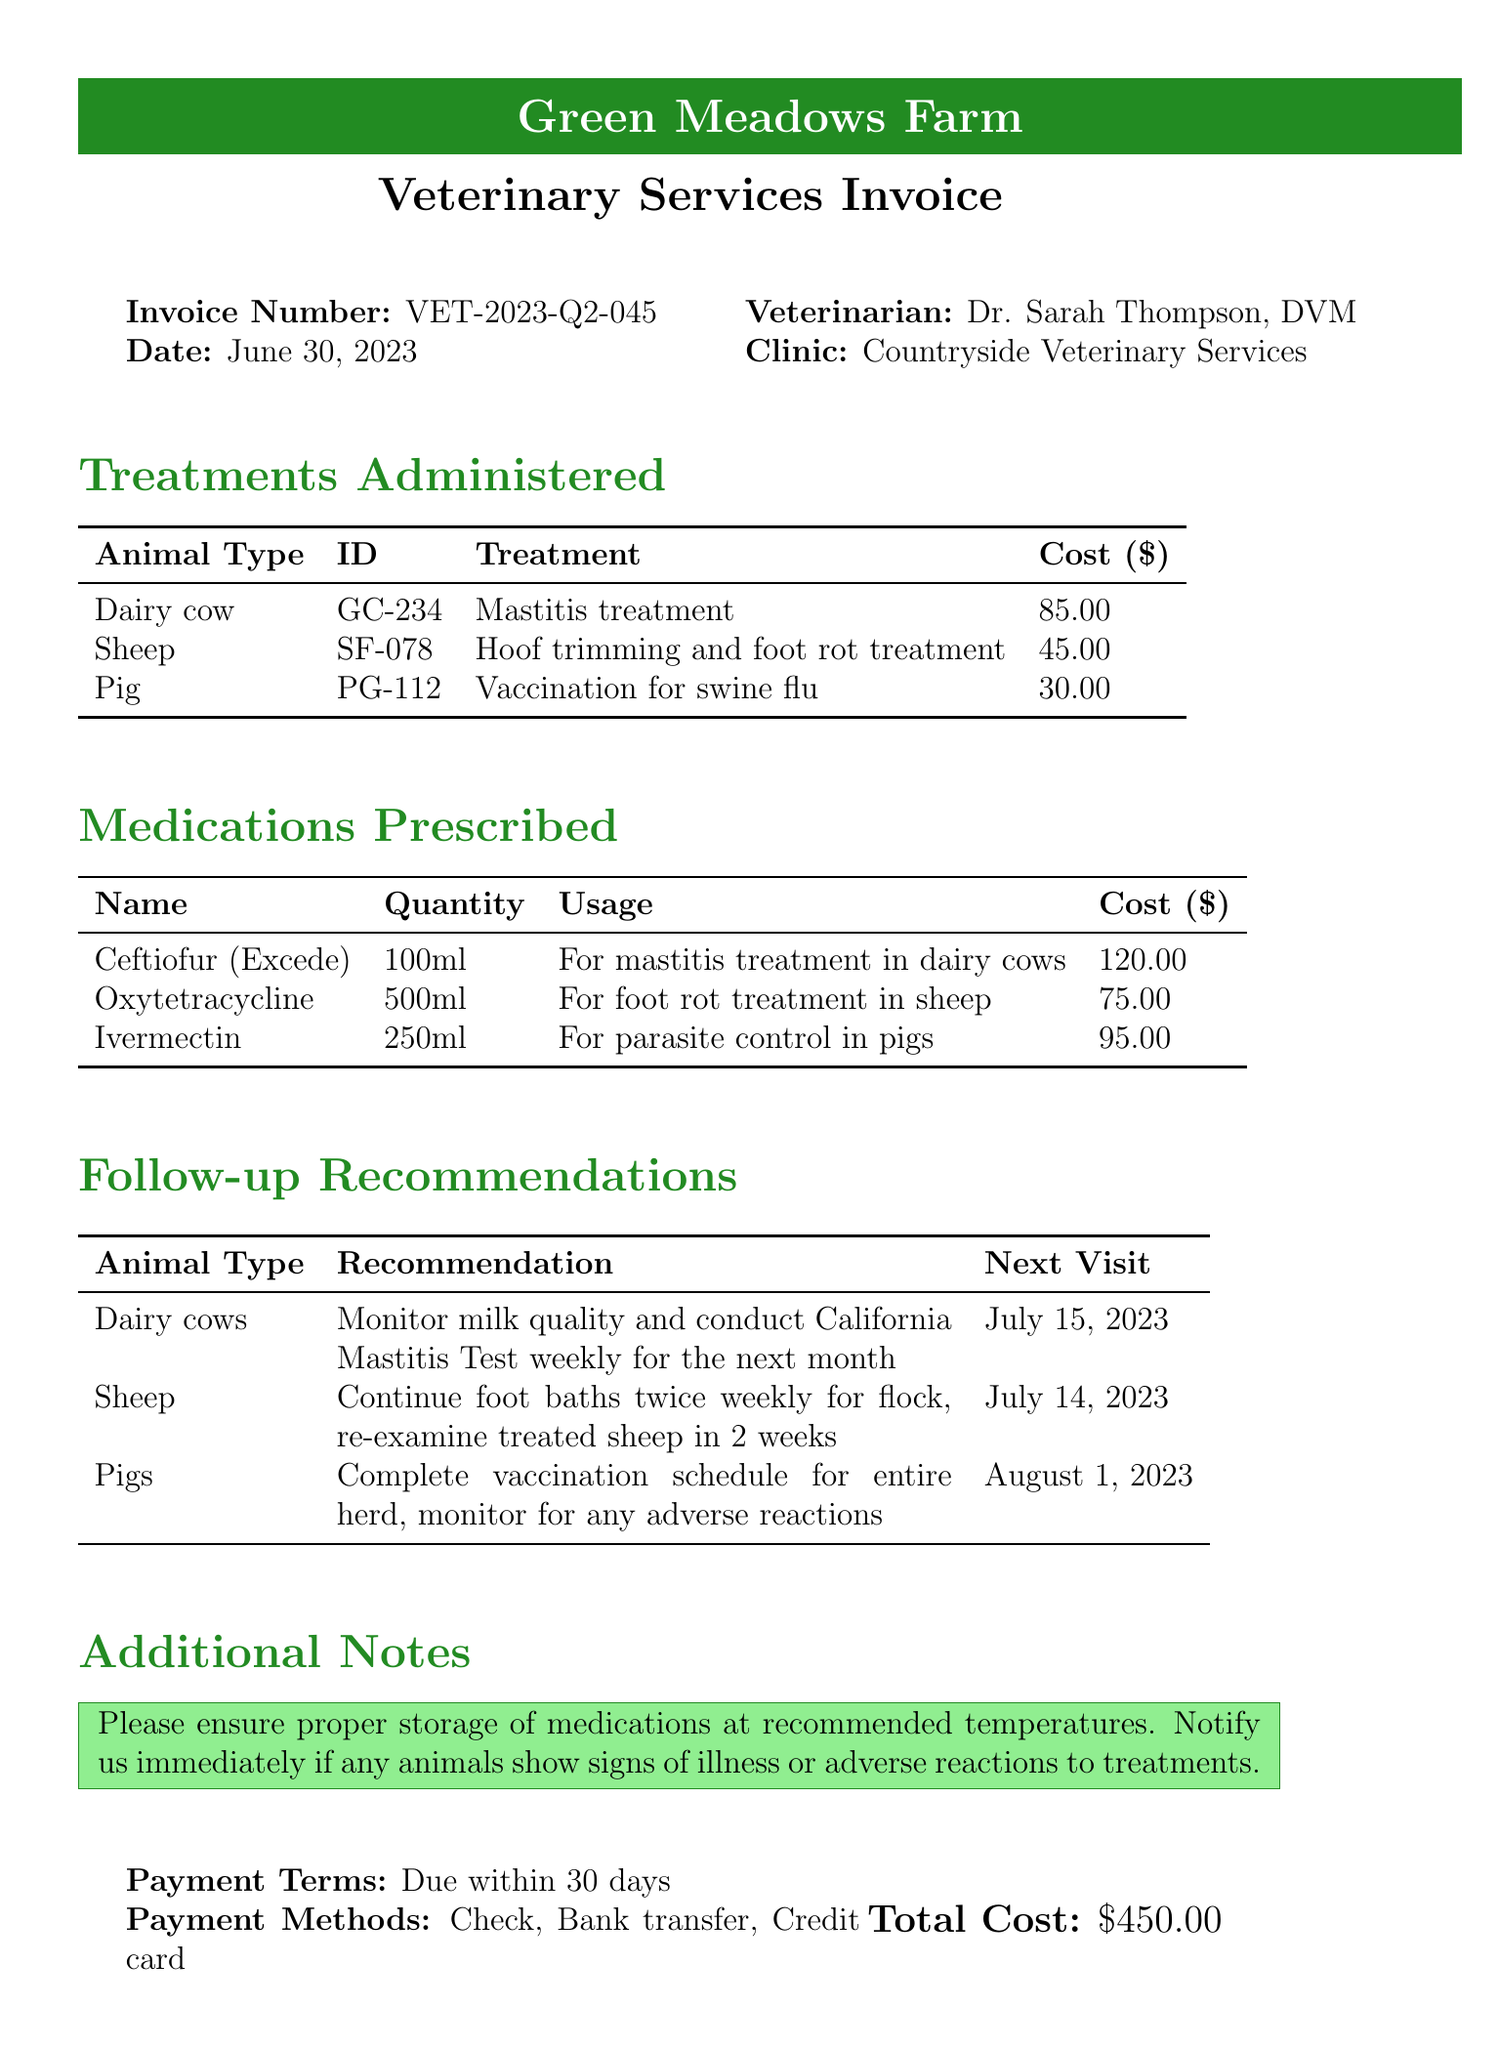What is the invoice number? The invoice number is explicitly stated in the document under "Invoice Number."
Answer: VET-2023-Q2-045 Who is the veterinarian? The name of the veterinarian is mentioned in the document's header section.
Answer: Dr. Sarah Thompson, DVM What date was the invoice issued? The date of the invoice is specified in the document.
Answer: June 30, 2023 How much is the total cost? The total cost is summarized at the end of the document.
Answer: $450.00 What treatment was administered to the dairy cow? The treatments administered include specific details about each animal type, including the dairy cow's treatment.
Answer: Mastitis treatment What medication was prescribed for foot rot treatment in sheep? The medications listed in the document provide details on usage for specific conditions.
Answer: Oxytetracycline When is the next visit for pigs? The follow-up recommendations include the scheduled date for the next visit for pigs.
Answer: August 1, 2023 What is the payment term stated in the document? The payment terms detail how long the payment is due after invoice issuance.
Answer: Due within 30 days What quantity of Ceftiofur was prescribed? The document specifies the quantity for each medication prescribed, including Ceftiofur.
Answer: 100ml 